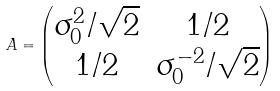<formula> <loc_0><loc_0><loc_500><loc_500>A = \begin{pmatrix} \sigma _ { 0 } ^ { 2 } / \sqrt { 2 } & 1 / 2 \\ 1 / 2 & \sigma _ { 0 } ^ { - 2 } / \sqrt { 2 } \end{pmatrix}</formula> 